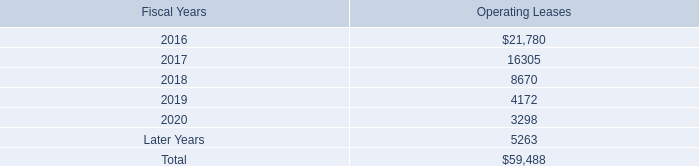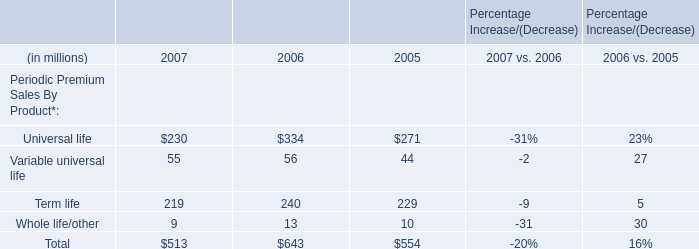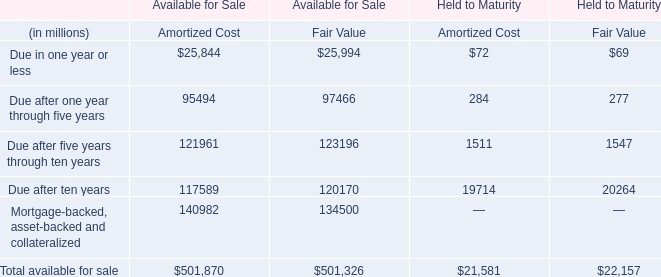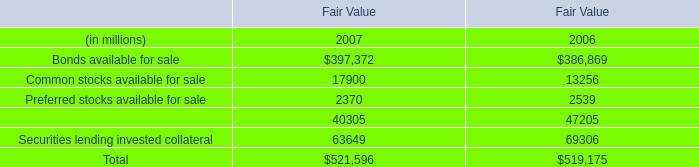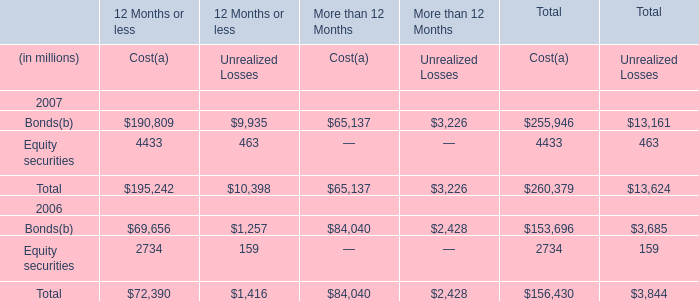What's the sum of Equity securities 2006 of 12 Months or less, Preferred stocks available for sale of Fair Value 2007, and Bonds 2006 of 12 Months or less Unrealized Losses ? 
Computations: ((2734.0 + 2370.0) + 1257.0)
Answer: 6361.0. 